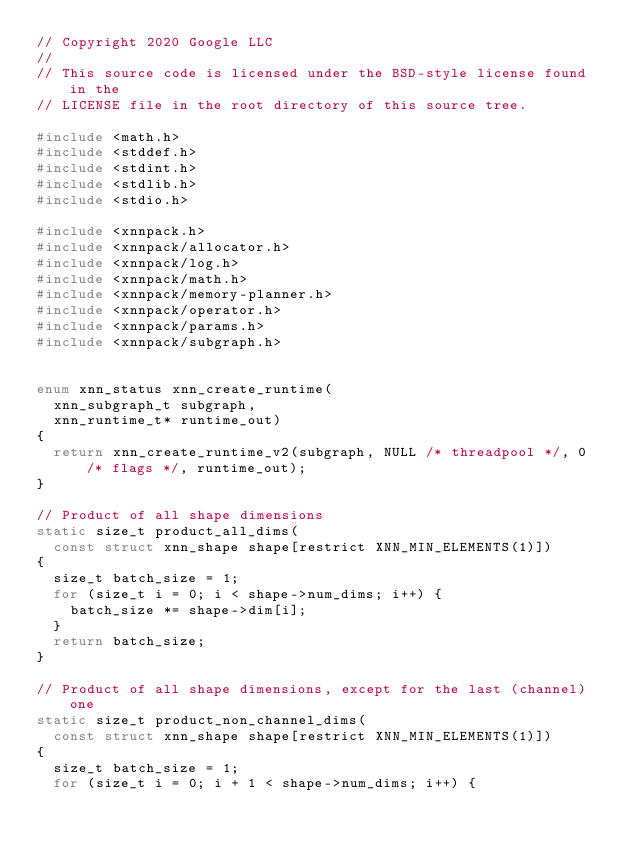Convert code to text. <code><loc_0><loc_0><loc_500><loc_500><_C_>// Copyright 2020 Google LLC
//
// This source code is licensed under the BSD-style license found in the
// LICENSE file in the root directory of this source tree.

#include <math.h>
#include <stddef.h>
#include <stdint.h>
#include <stdlib.h>
#include <stdio.h>

#include <xnnpack.h>
#include <xnnpack/allocator.h>
#include <xnnpack/log.h>
#include <xnnpack/math.h>
#include <xnnpack/memory-planner.h>
#include <xnnpack/operator.h>
#include <xnnpack/params.h>
#include <xnnpack/subgraph.h>


enum xnn_status xnn_create_runtime(
  xnn_subgraph_t subgraph,
  xnn_runtime_t* runtime_out)
{
  return xnn_create_runtime_v2(subgraph, NULL /* threadpool */, 0 /* flags */, runtime_out);
}

// Product of all shape dimensions
static size_t product_all_dims(
  const struct xnn_shape shape[restrict XNN_MIN_ELEMENTS(1)])
{
  size_t batch_size = 1;
  for (size_t i = 0; i < shape->num_dims; i++) {
    batch_size *= shape->dim[i];
  }
  return batch_size;
}

// Product of all shape dimensions, except for the last (channel) one
static size_t product_non_channel_dims(
  const struct xnn_shape shape[restrict XNN_MIN_ELEMENTS(1)])
{
  size_t batch_size = 1;
  for (size_t i = 0; i + 1 < shape->num_dims; i++) {</code> 